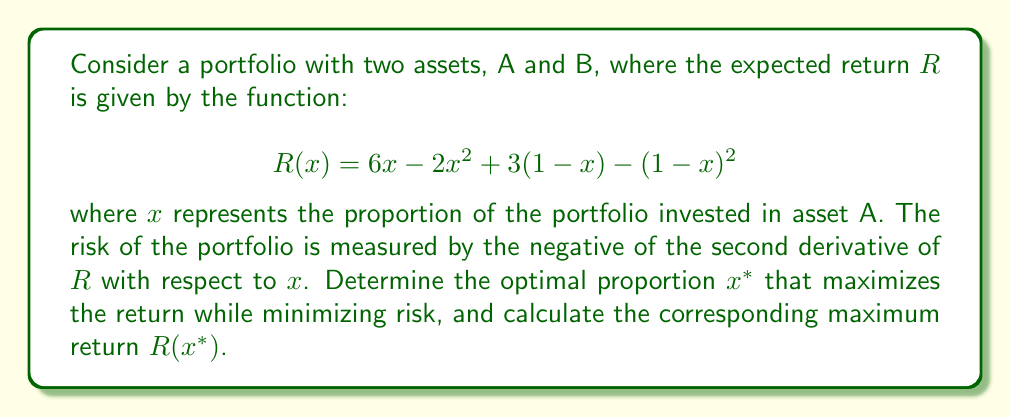Give your solution to this math problem. 1) First, we need to find the first and second derivatives of $R(x)$:

   $R(x) = 6x - 2x^2 + 3(1-x) - (1-x)^2$
   $R(x) = 6x - 2x^2 + 3 - 3x - 1 + 2x - x^2$
   $R(x) = -3x^2 + 5x + 2$

   First derivative: $R'(x) = -6x + 5$
   Second derivative: $R''(x) = -6$

2) The risk is measured by the negative of the second derivative:
   Risk $= -R''(x) = 6$

   Note that the risk is constant, independent of $x$.

3) To maximize return while minimizing risk, we find where $R'(x) = 0$:

   $-6x + 5 = 0$
   $-6x = -5$
   $x^* = \frac{5}{6}$

4) This critical point $x^* = \frac{5}{6}$ maximizes return because $R''(x) < 0$ for all $x$.

5) Calculate the maximum return:

   $R(x^*) = -3(\frac{5}{6})^2 + 5(\frac{5}{6}) + 2$
   $= -3(\frac{25}{36}) + \frac{25}{6} + 2$
   $= -\frac{25}{12} + \frac{25}{6} + 2$
   $= -\frac{25}{12} + \frac{50}{12} + \frac{24}{12}$
   $= \frac{49}{12}$
Answer: $x^* = \frac{5}{6}$, $R(x^*) = \frac{49}{12}$ 